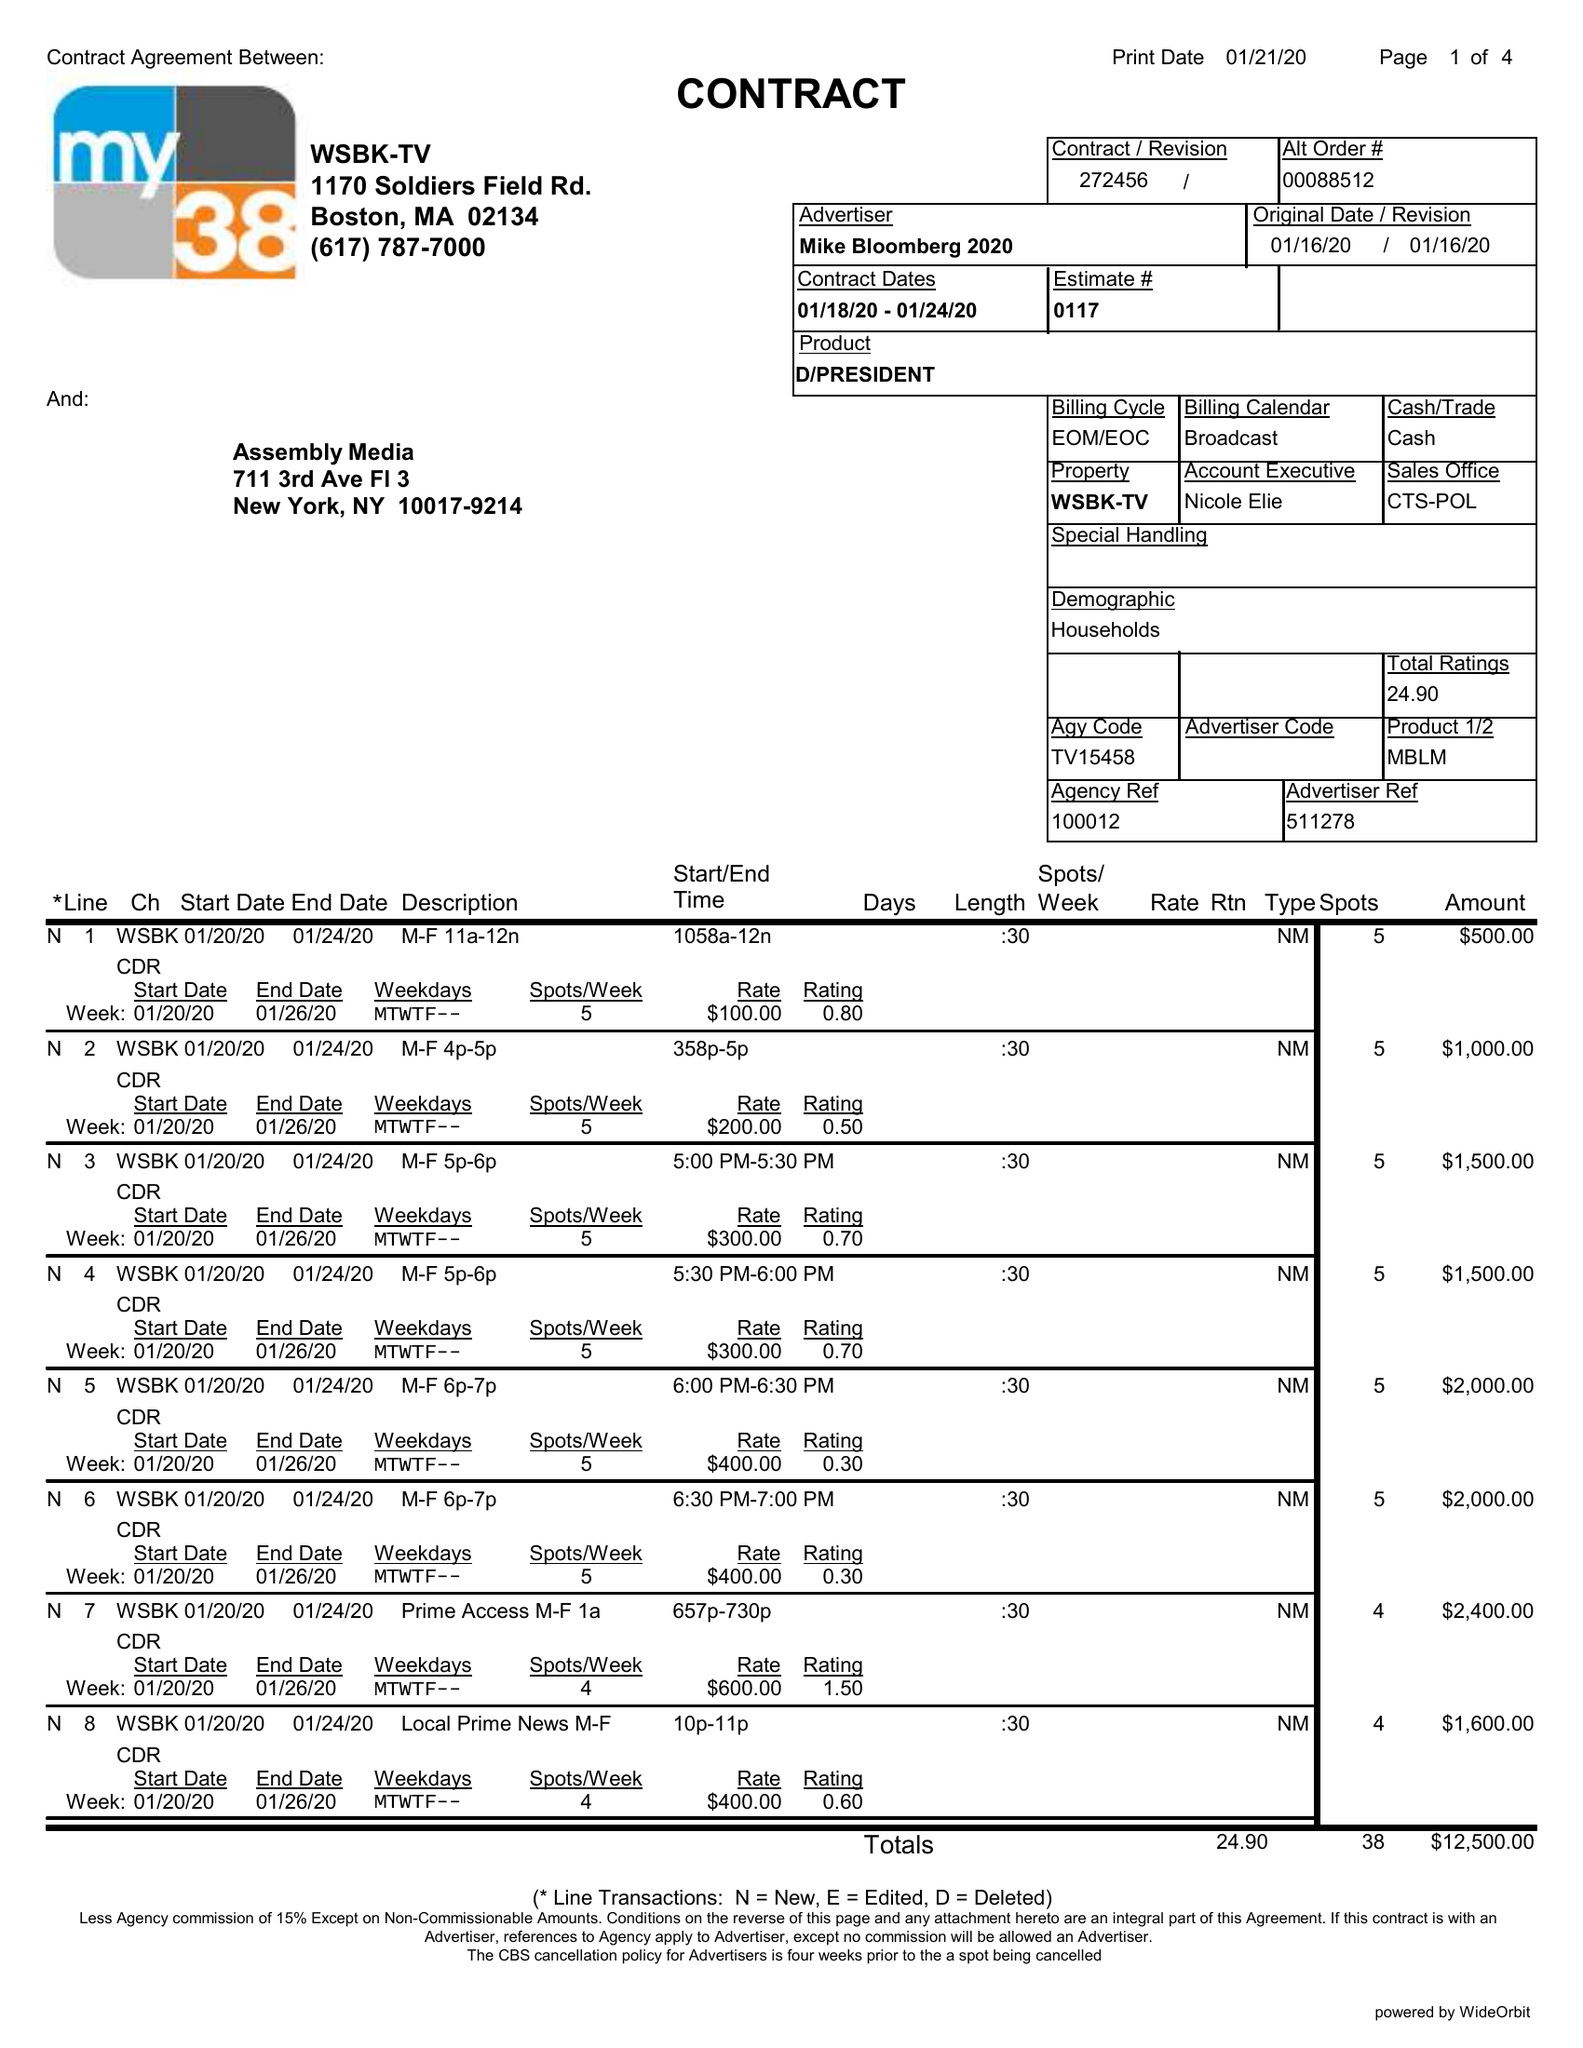What is the value for the gross_amount?
Answer the question using a single word or phrase. 12500.00 